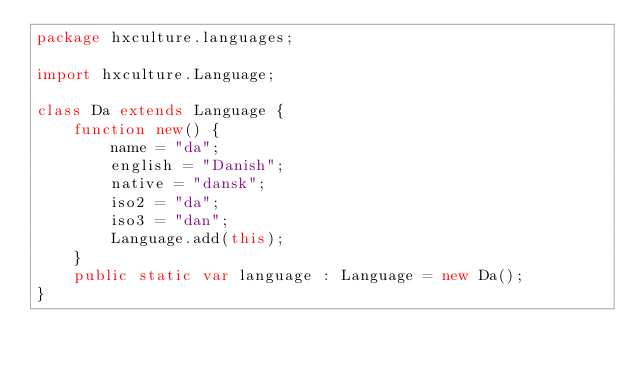Convert code to text. <code><loc_0><loc_0><loc_500><loc_500><_Haxe_>package hxculture.languages;

import hxculture.Language;

class Da extends Language {
	function new() {
		name = "da";
		english = "Danish";
		native = "dansk";
		iso2 = "da";
		iso3 = "dan";
		Language.add(this);
	}
	public static var language : Language = new Da();
}</code> 